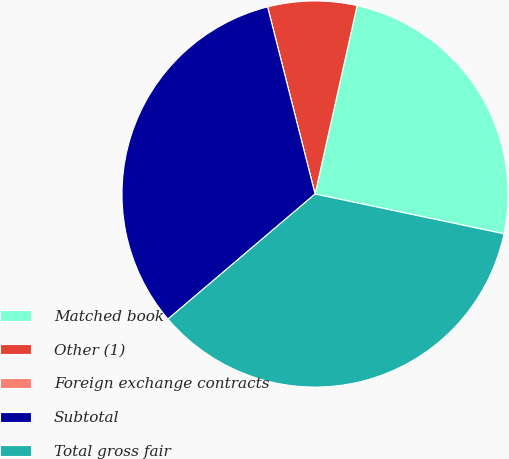Convert chart. <chart><loc_0><loc_0><loc_500><loc_500><pie_chart><fcel>Matched book<fcel>Other (1)<fcel>Foreign exchange contracts<fcel>Subtotal<fcel>Total gross fair<nl><fcel>24.81%<fcel>7.45%<fcel>0.0%<fcel>32.26%<fcel>35.48%<nl></chart> 